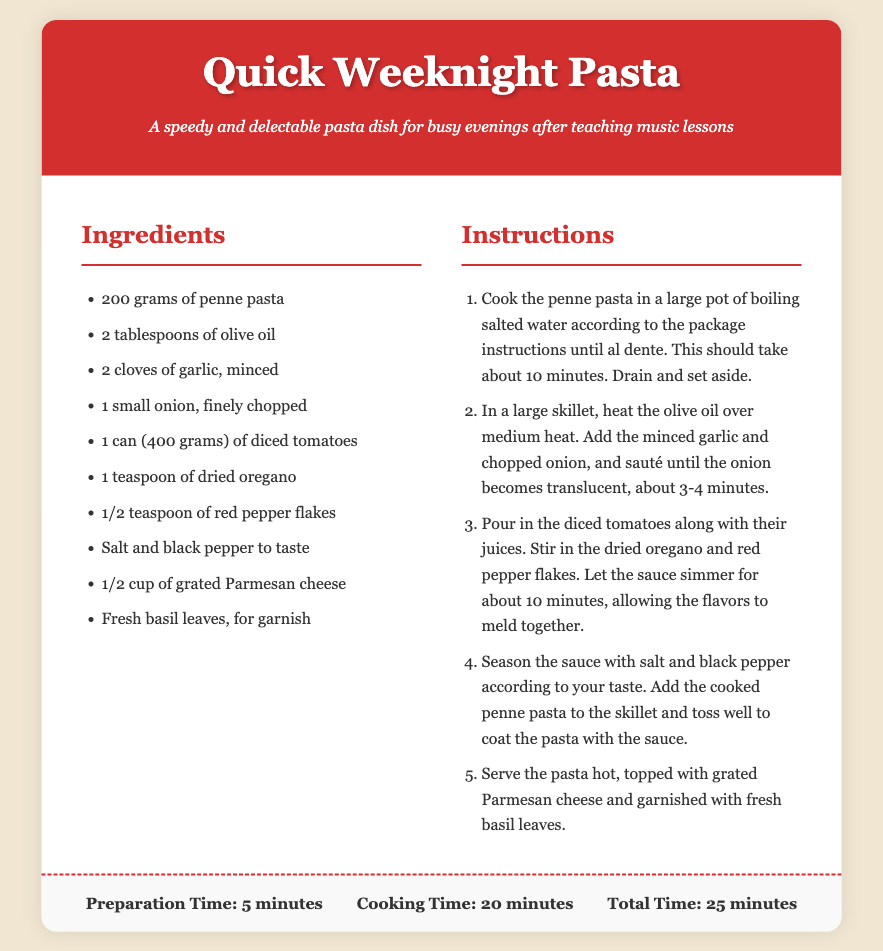What type of dish is Quick Weeknight Pasta? The title describes the dish as a "pasta," and the subtitle refers to it as a "pasta dish."
Answer: pasta How many grams of penne pasta are needed? The ingredients list specifies "200 grams of penne pasta."
Answer: 200 grams What is the cooking time for the penne pasta? The instructions indicate that cooking the pasta should take "about 10 minutes."
Answer: 10 minutes What ingredient is used to garnish the dish? The ingredients list mentions "Fresh basil leaves" for garnish.
Answer: Fresh basil leaves What is the total time to prepare this dish? The footer section provides the total time as "25 minutes."
Answer: 25 minutes How many cloves of garlic are required? The ingredients list states "2 cloves of garlic, minced."
Answer: 2 cloves What should you do to the diced tomatoes before adding them? The instructions say to "pour in the diced tomatoes along with their juices."
Answer: pour in How long should the sauce simmer? The instructions specify that the sauce should simmer for "about 10 minutes."
Answer: 10 minutes What ingredient is added to the sauce to enhance its flavor? The ingredients include "1 teaspoon of dried oregano" to enhance flavor.
Answer: 1 teaspoon of dried oregano What cooking method is used for the onion and garlic? The instructions will include the method "sauté" for cooking both onion and garlic.
Answer: sauté 